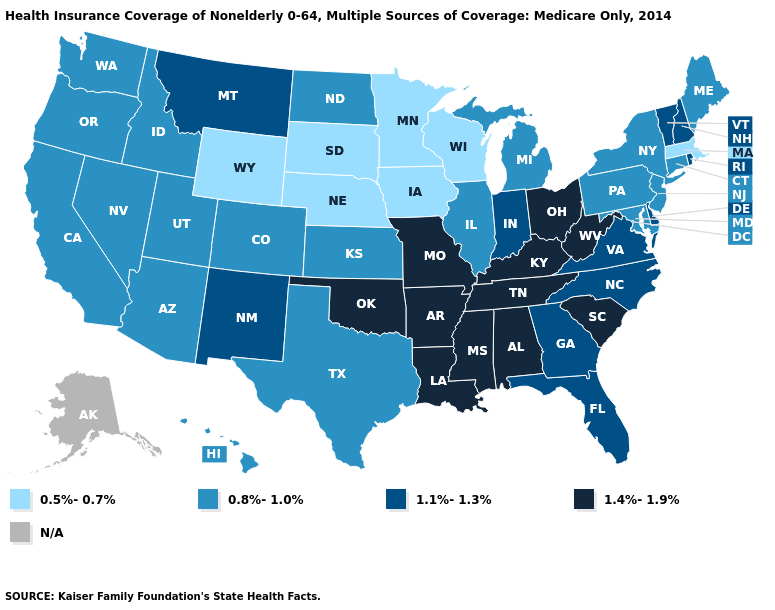What is the lowest value in states that border Virginia?
Give a very brief answer. 0.8%-1.0%. Which states have the lowest value in the South?
Be succinct. Maryland, Texas. Name the states that have a value in the range 1.1%-1.3%?
Answer briefly. Delaware, Florida, Georgia, Indiana, Montana, New Hampshire, New Mexico, North Carolina, Rhode Island, Vermont, Virginia. Which states hav the highest value in the South?
Short answer required. Alabama, Arkansas, Kentucky, Louisiana, Mississippi, Oklahoma, South Carolina, Tennessee, West Virginia. Is the legend a continuous bar?
Write a very short answer. No. Name the states that have a value in the range N/A?
Quick response, please. Alaska. Among the states that border Kentucky , does Indiana have the highest value?
Give a very brief answer. No. Among the states that border Arkansas , which have the lowest value?
Write a very short answer. Texas. Among the states that border New Jersey , does Delaware have the lowest value?
Be succinct. No. What is the highest value in states that border South Dakota?
Write a very short answer. 1.1%-1.3%. Does New Hampshire have the highest value in the Northeast?
Concise answer only. Yes. What is the lowest value in the West?
Be succinct. 0.5%-0.7%. Name the states that have a value in the range 0.5%-0.7%?
Quick response, please. Iowa, Massachusetts, Minnesota, Nebraska, South Dakota, Wisconsin, Wyoming. Name the states that have a value in the range 1.4%-1.9%?
Concise answer only. Alabama, Arkansas, Kentucky, Louisiana, Mississippi, Missouri, Ohio, Oklahoma, South Carolina, Tennessee, West Virginia. 